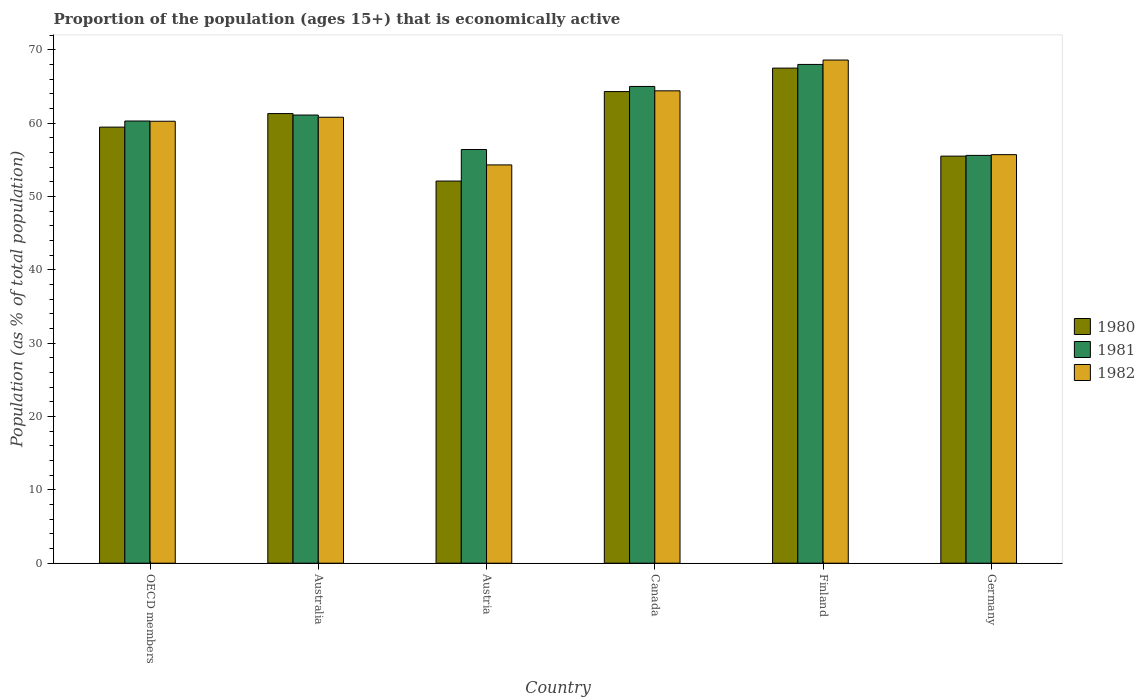How many groups of bars are there?
Offer a very short reply. 6. What is the label of the 4th group of bars from the left?
Offer a terse response. Canada. In how many cases, is the number of bars for a given country not equal to the number of legend labels?
Ensure brevity in your answer.  0. What is the proportion of the population that is economically active in 1982 in OECD members?
Keep it short and to the point. 60.25. Across all countries, what is the maximum proportion of the population that is economically active in 1980?
Your answer should be very brief. 67.5. Across all countries, what is the minimum proportion of the population that is economically active in 1982?
Ensure brevity in your answer.  54.3. In which country was the proportion of the population that is economically active in 1982 minimum?
Your answer should be compact. Austria. What is the total proportion of the population that is economically active in 1981 in the graph?
Offer a very short reply. 366.39. What is the difference between the proportion of the population that is economically active in 1980 in Australia and that in Finland?
Keep it short and to the point. -6.2. What is the average proportion of the population that is economically active in 1981 per country?
Your answer should be compact. 61.06. What is the difference between the proportion of the population that is economically active of/in 1981 and proportion of the population that is economically active of/in 1982 in Canada?
Offer a very short reply. 0.6. In how many countries, is the proportion of the population that is economically active in 1980 greater than 18 %?
Give a very brief answer. 6. What is the ratio of the proportion of the population that is economically active in 1980 in Finland to that in Germany?
Provide a short and direct response. 1.22. Is the proportion of the population that is economically active in 1982 in Finland less than that in OECD members?
Provide a short and direct response. No. Is the difference between the proportion of the population that is economically active in 1981 in Austria and Canada greater than the difference between the proportion of the population that is economically active in 1982 in Austria and Canada?
Offer a terse response. Yes. What is the difference between the highest and the second highest proportion of the population that is economically active in 1982?
Keep it short and to the point. -4.2. What is the difference between the highest and the lowest proportion of the population that is economically active in 1980?
Make the answer very short. 15.4. Is the sum of the proportion of the population that is economically active in 1982 in Australia and Finland greater than the maximum proportion of the population that is economically active in 1980 across all countries?
Give a very brief answer. Yes. How many bars are there?
Provide a succinct answer. 18. Are all the bars in the graph horizontal?
Ensure brevity in your answer.  No. How many countries are there in the graph?
Provide a short and direct response. 6. Does the graph contain any zero values?
Provide a short and direct response. No. Does the graph contain grids?
Provide a short and direct response. No. How many legend labels are there?
Offer a terse response. 3. What is the title of the graph?
Provide a succinct answer. Proportion of the population (ages 15+) that is economically active. Does "1998" appear as one of the legend labels in the graph?
Your answer should be very brief. No. What is the label or title of the Y-axis?
Provide a succinct answer. Population (as % of total population). What is the Population (as % of total population) in 1980 in OECD members?
Your response must be concise. 59.45. What is the Population (as % of total population) of 1981 in OECD members?
Your answer should be compact. 60.29. What is the Population (as % of total population) in 1982 in OECD members?
Keep it short and to the point. 60.25. What is the Population (as % of total population) in 1980 in Australia?
Ensure brevity in your answer.  61.3. What is the Population (as % of total population) in 1981 in Australia?
Your response must be concise. 61.1. What is the Population (as % of total population) of 1982 in Australia?
Your answer should be very brief. 60.8. What is the Population (as % of total population) in 1980 in Austria?
Your response must be concise. 52.1. What is the Population (as % of total population) in 1981 in Austria?
Provide a succinct answer. 56.4. What is the Population (as % of total population) of 1982 in Austria?
Provide a short and direct response. 54.3. What is the Population (as % of total population) of 1980 in Canada?
Your response must be concise. 64.3. What is the Population (as % of total population) in 1982 in Canada?
Ensure brevity in your answer.  64.4. What is the Population (as % of total population) in 1980 in Finland?
Give a very brief answer. 67.5. What is the Population (as % of total population) of 1982 in Finland?
Ensure brevity in your answer.  68.6. What is the Population (as % of total population) of 1980 in Germany?
Offer a terse response. 55.5. What is the Population (as % of total population) of 1981 in Germany?
Provide a short and direct response. 55.6. What is the Population (as % of total population) in 1982 in Germany?
Offer a terse response. 55.7. Across all countries, what is the maximum Population (as % of total population) of 1980?
Provide a short and direct response. 67.5. Across all countries, what is the maximum Population (as % of total population) of 1981?
Your response must be concise. 68. Across all countries, what is the maximum Population (as % of total population) of 1982?
Keep it short and to the point. 68.6. Across all countries, what is the minimum Population (as % of total population) in 1980?
Make the answer very short. 52.1. Across all countries, what is the minimum Population (as % of total population) of 1981?
Keep it short and to the point. 55.6. Across all countries, what is the minimum Population (as % of total population) in 1982?
Your answer should be very brief. 54.3. What is the total Population (as % of total population) in 1980 in the graph?
Ensure brevity in your answer.  360.15. What is the total Population (as % of total population) of 1981 in the graph?
Your answer should be very brief. 366.39. What is the total Population (as % of total population) in 1982 in the graph?
Offer a very short reply. 364.05. What is the difference between the Population (as % of total population) in 1980 in OECD members and that in Australia?
Provide a succinct answer. -1.85. What is the difference between the Population (as % of total population) of 1981 in OECD members and that in Australia?
Your answer should be very brief. -0.81. What is the difference between the Population (as % of total population) of 1982 in OECD members and that in Australia?
Your answer should be very brief. -0.55. What is the difference between the Population (as % of total population) in 1980 in OECD members and that in Austria?
Offer a very short reply. 7.35. What is the difference between the Population (as % of total population) of 1981 in OECD members and that in Austria?
Your answer should be compact. 3.89. What is the difference between the Population (as % of total population) in 1982 in OECD members and that in Austria?
Your answer should be very brief. 5.95. What is the difference between the Population (as % of total population) of 1980 in OECD members and that in Canada?
Make the answer very short. -4.85. What is the difference between the Population (as % of total population) of 1981 in OECD members and that in Canada?
Provide a succinct answer. -4.71. What is the difference between the Population (as % of total population) of 1982 in OECD members and that in Canada?
Your answer should be very brief. -4.15. What is the difference between the Population (as % of total population) in 1980 in OECD members and that in Finland?
Offer a very short reply. -8.05. What is the difference between the Population (as % of total population) in 1981 in OECD members and that in Finland?
Your response must be concise. -7.71. What is the difference between the Population (as % of total population) in 1982 in OECD members and that in Finland?
Ensure brevity in your answer.  -8.35. What is the difference between the Population (as % of total population) in 1980 in OECD members and that in Germany?
Your response must be concise. 3.95. What is the difference between the Population (as % of total population) of 1981 in OECD members and that in Germany?
Provide a succinct answer. 4.69. What is the difference between the Population (as % of total population) of 1982 in OECD members and that in Germany?
Your answer should be compact. 4.55. What is the difference between the Population (as % of total population) of 1981 in Australia and that in Austria?
Offer a terse response. 4.7. What is the difference between the Population (as % of total population) of 1980 in Australia and that in Canada?
Keep it short and to the point. -3. What is the difference between the Population (as % of total population) in 1980 in Australia and that in Finland?
Your answer should be compact. -6.2. What is the difference between the Population (as % of total population) in 1981 in Australia and that in Finland?
Ensure brevity in your answer.  -6.9. What is the difference between the Population (as % of total population) in 1980 in Australia and that in Germany?
Offer a very short reply. 5.8. What is the difference between the Population (as % of total population) of 1981 in Australia and that in Germany?
Offer a very short reply. 5.5. What is the difference between the Population (as % of total population) in 1982 in Australia and that in Germany?
Provide a succinct answer. 5.1. What is the difference between the Population (as % of total population) in 1980 in Austria and that in Canada?
Provide a short and direct response. -12.2. What is the difference between the Population (as % of total population) in 1981 in Austria and that in Canada?
Provide a succinct answer. -8.6. What is the difference between the Population (as % of total population) of 1980 in Austria and that in Finland?
Provide a short and direct response. -15.4. What is the difference between the Population (as % of total population) in 1981 in Austria and that in Finland?
Your response must be concise. -11.6. What is the difference between the Population (as % of total population) in 1982 in Austria and that in Finland?
Give a very brief answer. -14.3. What is the difference between the Population (as % of total population) of 1981 in Austria and that in Germany?
Your response must be concise. 0.8. What is the difference between the Population (as % of total population) of 1982 in Austria and that in Germany?
Provide a succinct answer. -1.4. What is the difference between the Population (as % of total population) of 1982 in Canada and that in Finland?
Your answer should be very brief. -4.2. What is the difference between the Population (as % of total population) of 1980 in Canada and that in Germany?
Provide a succinct answer. 8.8. What is the difference between the Population (as % of total population) in 1981 in Canada and that in Germany?
Your response must be concise. 9.4. What is the difference between the Population (as % of total population) in 1980 in Finland and that in Germany?
Your answer should be very brief. 12. What is the difference between the Population (as % of total population) in 1980 in OECD members and the Population (as % of total population) in 1981 in Australia?
Your response must be concise. -1.65. What is the difference between the Population (as % of total population) of 1980 in OECD members and the Population (as % of total population) of 1982 in Australia?
Your answer should be compact. -1.35. What is the difference between the Population (as % of total population) in 1981 in OECD members and the Population (as % of total population) in 1982 in Australia?
Your answer should be compact. -0.51. What is the difference between the Population (as % of total population) in 1980 in OECD members and the Population (as % of total population) in 1981 in Austria?
Your answer should be compact. 3.05. What is the difference between the Population (as % of total population) of 1980 in OECD members and the Population (as % of total population) of 1982 in Austria?
Offer a terse response. 5.15. What is the difference between the Population (as % of total population) in 1981 in OECD members and the Population (as % of total population) in 1982 in Austria?
Make the answer very short. 5.99. What is the difference between the Population (as % of total population) of 1980 in OECD members and the Population (as % of total population) of 1981 in Canada?
Your answer should be very brief. -5.55. What is the difference between the Population (as % of total population) of 1980 in OECD members and the Population (as % of total population) of 1982 in Canada?
Offer a very short reply. -4.95. What is the difference between the Population (as % of total population) of 1981 in OECD members and the Population (as % of total population) of 1982 in Canada?
Give a very brief answer. -4.11. What is the difference between the Population (as % of total population) in 1980 in OECD members and the Population (as % of total population) in 1981 in Finland?
Your answer should be very brief. -8.55. What is the difference between the Population (as % of total population) in 1980 in OECD members and the Population (as % of total population) in 1982 in Finland?
Provide a short and direct response. -9.15. What is the difference between the Population (as % of total population) in 1981 in OECD members and the Population (as % of total population) in 1982 in Finland?
Make the answer very short. -8.31. What is the difference between the Population (as % of total population) in 1980 in OECD members and the Population (as % of total population) in 1981 in Germany?
Keep it short and to the point. 3.85. What is the difference between the Population (as % of total population) in 1980 in OECD members and the Population (as % of total population) in 1982 in Germany?
Your answer should be compact. 3.75. What is the difference between the Population (as % of total population) in 1981 in OECD members and the Population (as % of total population) in 1982 in Germany?
Your answer should be compact. 4.59. What is the difference between the Population (as % of total population) of 1981 in Australia and the Population (as % of total population) of 1982 in Austria?
Make the answer very short. 6.8. What is the difference between the Population (as % of total population) in 1980 in Australia and the Population (as % of total population) in 1981 in Canada?
Keep it short and to the point. -3.7. What is the difference between the Population (as % of total population) of 1980 in Australia and the Population (as % of total population) of 1982 in Canada?
Make the answer very short. -3.1. What is the difference between the Population (as % of total population) in 1980 in Australia and the Population (as % of total population) in 1982 in Finland?
Provide a short and direct response. -7.3. What is the difference between the Population (as % of total population) in 1981 in Australia and the Population (as % of total population) in 1982 in Germany?
Your answer should be compact. 5.4. What is the difference between the Population (as % of total population) of 1980 in Austria and the Population (as % of total population) of 1982 in Canada?
Make the answer very short. -12.3. What is the difference between the Population (as % of total population) of 1980 in Austria and the Population (as % of total population) of 1981 in Finland?
Provide a succinct answer. -15.9. What is the difference between the Population (as % of total population) of 1980 in Austria and the Population (as % of total population) of 1982 in Finland?
Your answer should be compact. -16.5. What is the difference between the Population (as % of total population) of 1981 in Austria and the Population (as % of total population) of 1982 in Finland?
Ensure brevity in your answer.  -12.2. What is the difference between the Population (as % of total population) in 1980 in Austria and the Population (as % of total population) in 1981 in Germany?
Keep it short and to the point. -3.5. What is the difference between the Population (as % of total population) in 1980 in Austria and the Population (as % of total population) in 1982 in Germany?
Ensure brevity in your answer.  -3.6. What is the difference between the Population (as % of total population) in 1981 in Austria and the Population (as % of total population) in 1982 in Germany?
Give a very brief answer. 0.7. What is the difference between the Population (as % of total population) in 1981 in Canada and the Population (as % of total population) in 1982 in Finland?
Keep it short and to the point. -3.6. What is the difference between the Population (as % of total population) of 1980 in Canada and the Population (as % of total population) of 1981 in Germany?
Your answer should be very brief. 8.7. What is the difference between the Population (as % of total population) of 1980 in Canada and the Population (as % of total population) of 1982 in Germany?
Provide a short and direct response. 8.6. What is the difference between the Population (as % of total population) in 1980 in Finland and the Population (as % of total population) in 1981 in Germany?
Your answer should be very brief. 11.9. What is the difference between the Population (as % of total population) in 1980 in Finland and the Population (as % of total population) in 1982 in Germany?
Make the answer very short. 11.8. What is the average Population (as % of total population) of 1980 per country?
Provide a short and direct response. 60.03. What is the average Population (as % of total population) of 1981 per country?
Provide a succinct answer. 61.06. What is the average Population (as % of total population) in 1982 per country?
Make the answer very short. 60.68. What is the difference between the Population (as % of total population) in 1980 and Population (as % of total population) in 1981 in OECD members?
Provide a succinct answer. -0.83. What is the difference between the Population (as % of total population) in 1980 and Population (as % of total population) in 1982 in OECD members?
Give a very brief answer. -0.8. What is the difference between the Population (as % of total population) of 1981 and Population (as % of total population) of 1982 in OECD members?
Provide a succinct answer. 0.03. What is the difference between the Population (as % of total population) of 1980 and Population (as % of total population) of 1981 in Australia?
Your response must be concise. 0.2. What is the difference between the Population (as % of total population) in 1980 and Population (as % of total population) in 1982 in Australia?
Keep it short and to the point. 0.5. What is the difference between the Population (as % of total population) of 1981 and Population (as % of total population) of 1982 in Australia?
Your answer should be very brief. 0.3. What is the difference between the Population (as % of total population) of 1980 and Population (as % of total population) of 1982 in Austria?
Keep it short and to the point. -2.2. What is the difference between the Population (as % of total population) of 1981 and Population (as % of total population) of 1982 in Austria?
Your answer should be compact. 2.1. What is the difference between the Population (as % of total population) in 1980 and Population (as % of total population) in 1981 in Canada?
Offer a very short reply. -0.7. What is the difference between the Population (as % of total population) in 1980 and Population (as % of total population) in 1982 in Canada?
Provide a succinct answer. -0.1. What is the difference between the Population (as % of total population) of 1980 and Population (as % of total population) of 1981 in Finland?
Ensure brevity in your answer.  -0.5. What is the difference between the Population (as % of total population) of 1980 and Population (as % of total population) of 1982 in Finland?
Keep it short and to the point. -1.1. What is the difference between the Population (as % of total population) of 1981 and Population (as % of total population) of 1982 in Finland?
Provide a short and direct response. -0.6. What is the ratio of the Population (as % of total population) in 1980 in OECD members to that in Australia?
Make the answer very short. 0.97. What is the ratio of the Population (as % of total population) of 1981 in OECD members to that in Australia?
Your response must be concise. 0.99. What is the ratio of the Population (as % of total population) of 1982 in OECD members to that in Australia?
Provide a short and direct response. 0.99. What is the ratio of the Population (as % of total population) of 1980 in OECD members to that in Austria?
Give a very brief answer. 1.14. What is the ratio of the Population (as % of total population) in 1981 in OECD members to that in Austria?
Give a very brief answer. 1.07. What is the ratio of the Population (as % of total population) in 1982 in OECD members to that in Austria?
Provide a short and direct response. 1.11. What is the ratio of the Population (as % of total population) in 1980 in OECD members to that in Canada?
Make the answer very short. 0.92. What is the ratio of the Population (as % of total population) in 1981 in OECD members to that in Canada?
Your response must be concise. 0.93. What is the ratio of the Population (as % of total population) in 1982 in OECD members to that in Canada?
Make the answer very short. 0.94. What is the ratio of the Population (as % of total population) of 1980 in OECD members to that in Finland?
Provide a short and direct response. 0.88. What is the ratio of the Population (as % of total population) of 1981 in OECD members to that in Finland?
Provide a short and direct response. 0.89. What is the ratio of the Population (as % of total population) of 1982 in OECD members to that in Finland?
Your answer should be compact. 0.88. What is the ratio of the Population (as % of total population) of 1980 in OECD members to that in Germany?
Provide a succinct answer. 1.07. What is the ratio of the Population (as % of total population) in 1981 in OECD members to that in Germany?
Offer a terse response. 1.08. What is the ratio of the Population (as % of total population) in 1982 in OECD members to that in Germany?
Ensure brevity in your answer.  1.08. What is the ratio of the Population (as % of total population) of 1980 in Australia to that in Austria?
Offer a very short reply. 1.18. What is the ratio of the Population (as % of total population) of 1981 in Australia to that in Austria?
Offer a very short reply. 1.08. What is the ratio of the Population (as % of total population) of 1982 in Australia to that in Austria?
Your answer should be compact. 1.12. What is the ratio of the Population (as % of total population) in 1980 in Australia to that in Canada?
Provide a succinct answer. 0.95. What is the ratio of the Population (as % of total population) in 1981 in Australia to that in Canada?
Your answer should be compact. 0.94. What is the ratio of the Population (as % of total population) in 1982 in Australia to that in Canada?
Your response must be concise. 0.94. What is the ratio of the Population (as % of total population) in 1980 in Australia to that in Finland?
Keep it short and to the point. 0.91. What is the ratio of the Population (as % of total population) in 1981 in Australia to that in Finland?
Offer a terse response. 0.9. What is the ratio of the Population (as % of total population) in 1982 in Australia to that in Finland?
Keep it short and to the point. 0.89. What is the ratio of the Population (as % of total population) of 1980 in Australia to that in Germany?
Give a very brief answer. 1.1. What is the ratio of the Population (as % of total population) of 1981 in Australia to that in Germany?
Offer a terse response. 1.1. What is the ratio of the Population (as % of total population) in 1982 in Australia to that in Germany?
Offer a very short reply. 1.09. What is the ratio of the Population (as % of total population) in 1980 in Austria to that in Canada?
Provide a succinct answer. 0.81. What is the ratio of the Population (as % of total population) in 1981 in Austria to that in Canada?
Provide a succinct answer. 0.87. What is the ratio of the Population (as % of total population) of 1982 in Austria to that in Canada?
Offer a terse response. 0.84. What is the ratio of the Population (as % of total population) of 1980 in Austria to that in Finland?
Keep it short and to the point. 0.77. What is the ratio of the Population (as % of total population) of 1981 in Austria to that in Finland?
Provide a succinct answer. 0.83. What is the ratio of the Population (as % of total population) of 1982 in Austria to that in Finland?
Your answer should be very brief. 0.79. What is the ratio of the Population (as % of total population) of 1980 in Austria to that in Germany?
Provide a short and direct response. 0.94. What is the ratio of the Population (as % of total population) of 1981 in Austria to that in Germany?
Your response must be concise. 1.01. What is the ratio of the Population (as % of total population) of 1982 in Austria to that in Germany?
Make the answer very short. 0.97. What is the ratio of the Population (as % of total population) of 1980 in Canada to that in Finland?
Provide a short and direct response. 0.95. What is the ratio of the Population (as % of total population) of 1981 in Canada to that in Finland?
Give a very brief answer. 0.96. What is the ratio of the Population (as % of total population) in 1982 in Canada to that in Finland?
Your answer should be very brief. 0.94. What is the ratio of the Population (as % of total population) in 1980 in Canada to that in Germany?
Keep it short and to the point. 1.16. What is the ratio of the Population (as % of total population) of 1981 in Canada to that in Germany?
Offer a very short reply. 1.17. What is the ratio of the Population (as % of total population) in 1982 in Canada to that in Germany?
Offer a very short reply. 1.16. What is the ratio of the Population (as % of total population) in 1980 in Finland to that in Germany?
Make the answer very short. 1.22. What is the ratio of the Population (as % of total population) of 1981 in Finland to that in Germany?
Provide a short and direct response. 1.22. What is the ratio of the Population (as % of total population) in 1982 in Finland to that in Germany?
Keep it short and to the point. 1.23. What is the difference between the highest and the second highest Population (as % of total population) of 1982?
Provide a succinct answer. 4.2. What is the difference between the highest and the lowest Population (as % of total population) of 1980?
Ensure brevity in your answer.  15.4. 